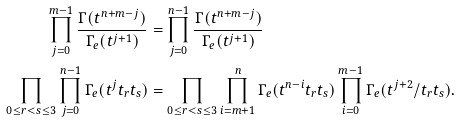Convert formula to latex. <formula><loc_0><loc_0><loc_500><loc_500>\prod _ { j = 0 } ^ { m - 1 } \frac { \Gamma ( t ^ { n + m - j } ) } { \Gamma _ { e } ( t ^ { j + 1 } ) } & = \prod _ { j = 0 } ^ { n - 1 } \frac { \Gamma ( t ^ { n + m - j } ) } { \Gamma _ { e } ( t ^ { j + 1 } ) } \\ \prod _ { 0 \leq r < s \leq 3 } \prod _ { j = 0 } ^ { n - 1 } \Gamma _ { e } ( t ^ { j } t _ { r } t _ { s } ) & = \prod _ { 0 \leq r < s \leq 3 } \prod _ { i = m + 1 } ^ { n } \Gamma _ { e } ( t ^ { n - i } t _ { r } t _ { s } ) \prod _ { i = 0 } ^ { m - 1 } \Gamma _ { e } ( t ^ { j + 2 } / t _ { r } t _ { s } ) .</formula> 